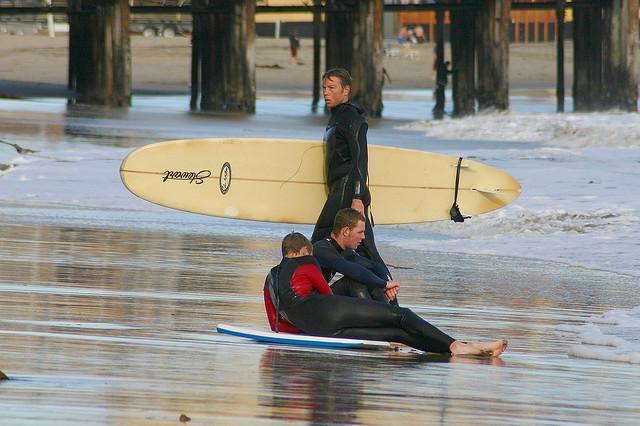How many dudes are here?
Give a very brief answer. 3. How many of these people are standing?
Give a very brief answer. 1. How many people are there?
Give a very brief answer. 1. How many elephants are there?
Give a very brief answer. 0. 